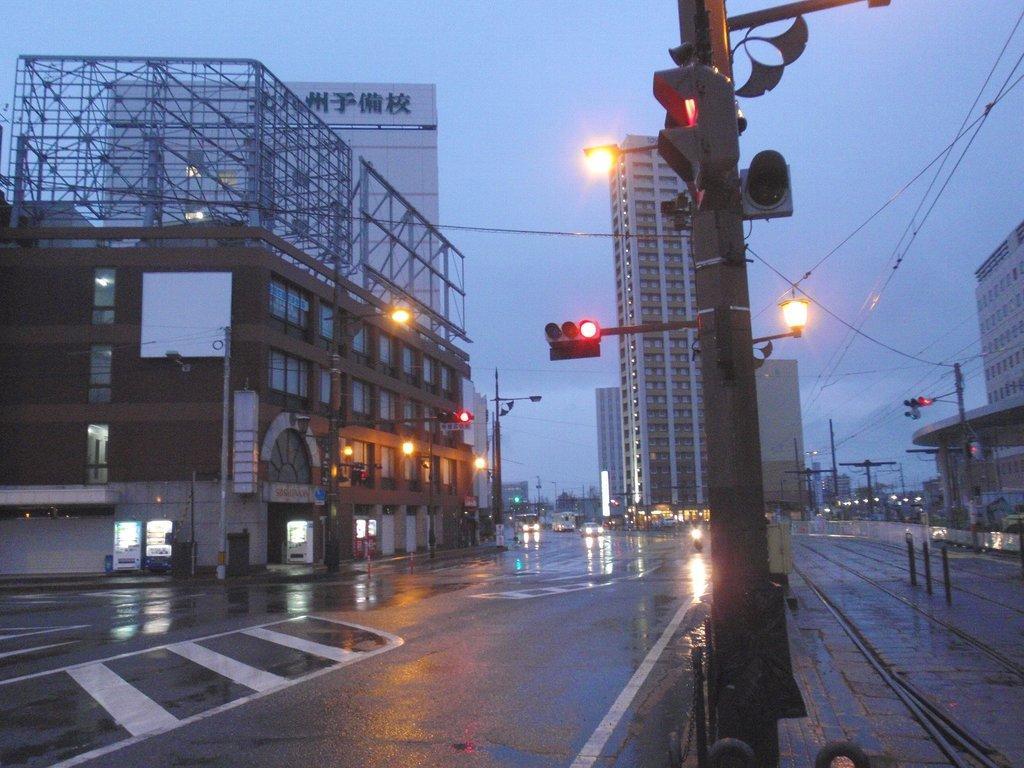Could you give a brief overview of what you see in this image? In this image I can see a road in the centre and on it I can see number of vehicles. On the both sides of the road I can see number of buildings, number of poles, signal lights, street lights and number of wires. On the top left side of the image I can see a white colour board and on it I can see something is written. In the background I can see the sky. 